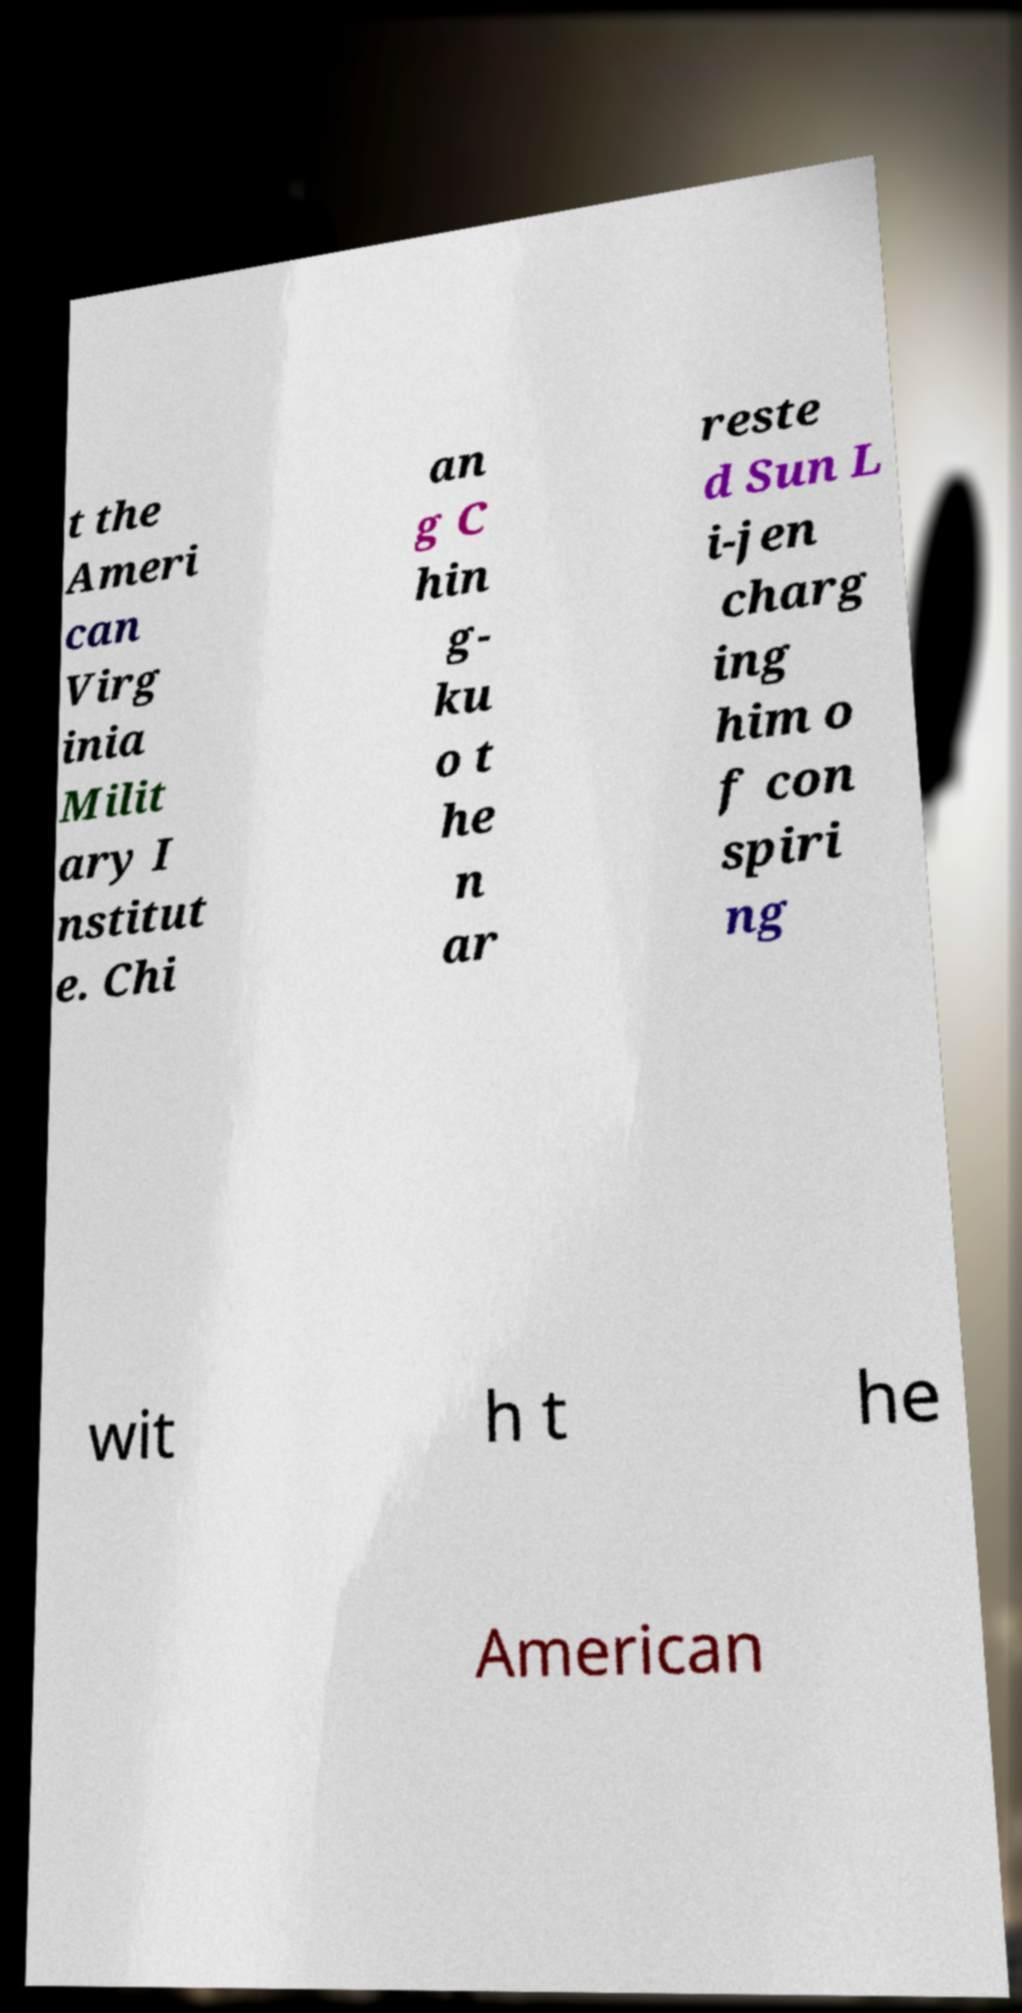Please read and relay the text visible in this image. What does it say? t the Ameri can Virg inia Milit ary I nstitut e. Chi an g C hin g- ku o t he n ar reste d Sun L i-jen charg ing him o f con spiri ng wit h t he American 